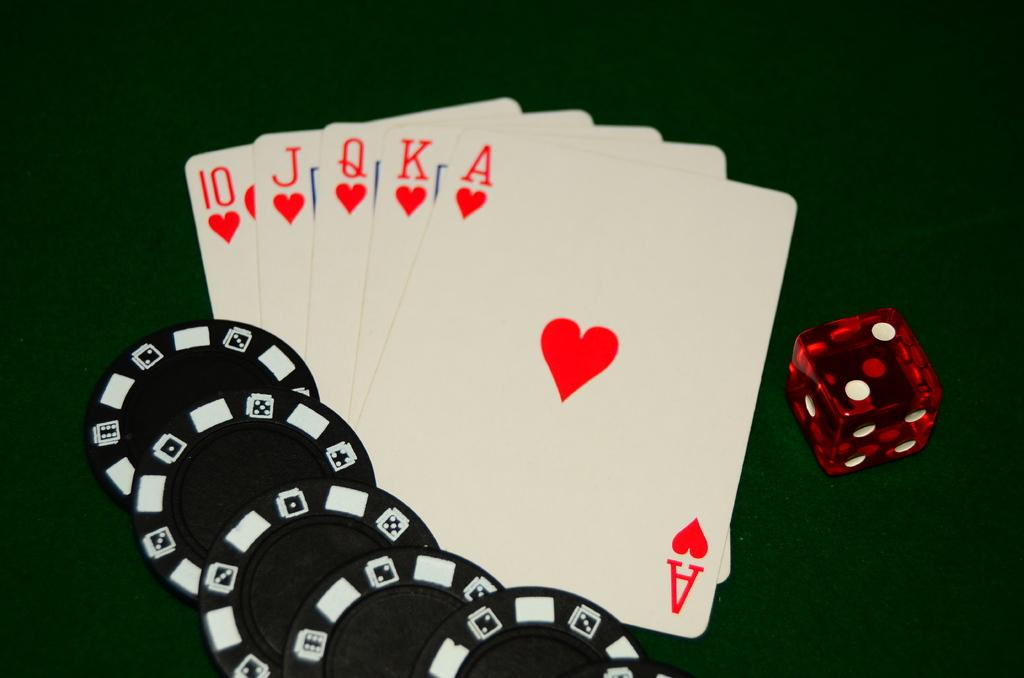<image>
Offer a succinct explanation of the picture presented. a set of cards with the A card on top 